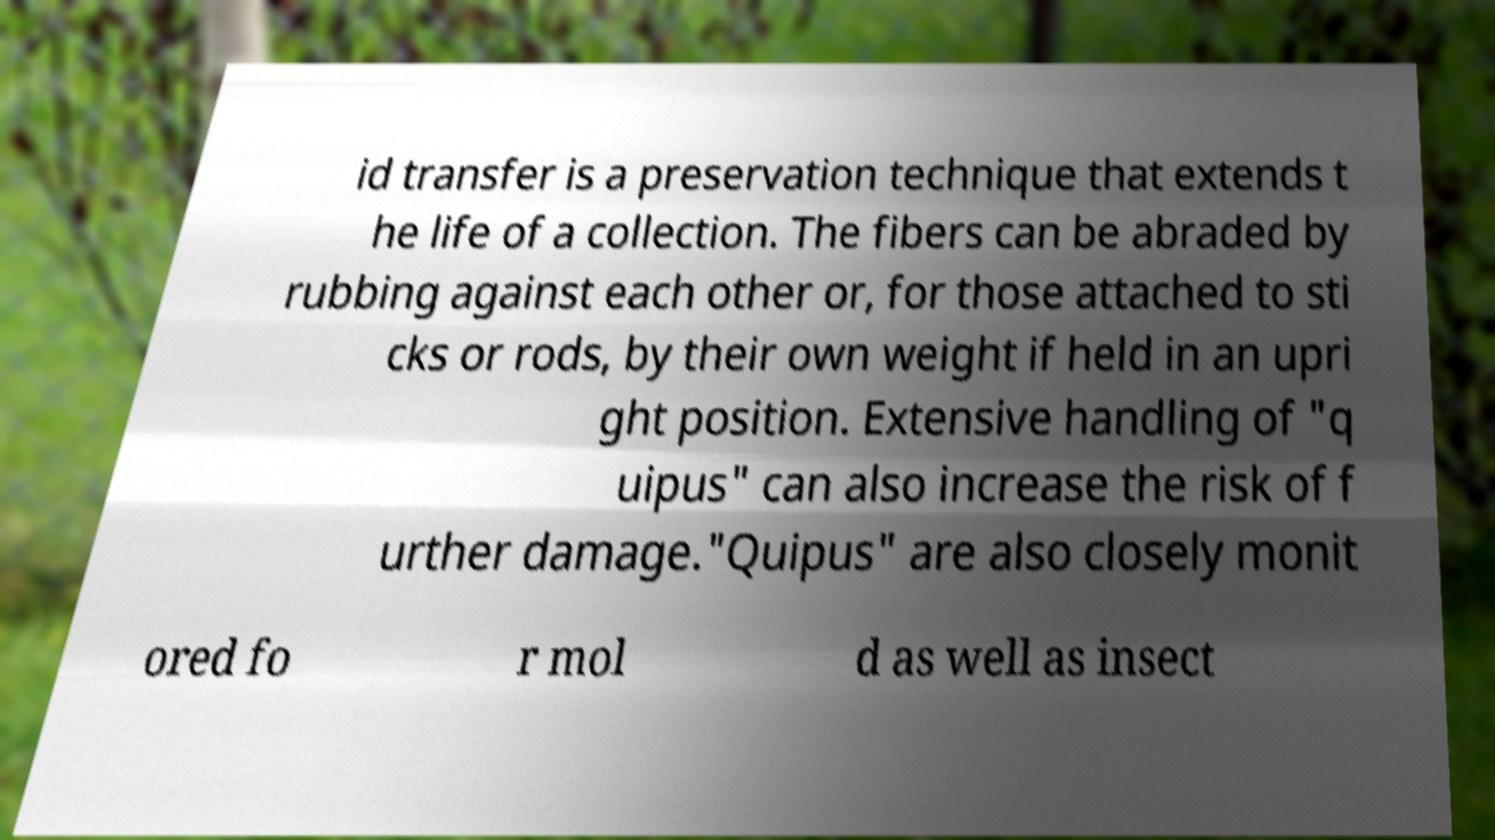Could you extract and type out the text from this image? id transfer is a preservation technique that extends t he life of a collection. The fibers can be abraded by rubbing against each other or, for those attached to sti cks or rods, by their own weight if held in an upri ght position. Extensive handling of "q uipus" can also increase the risk of f urther damage."Quipus" are also closely monit ored fo r mol d as well as insect 